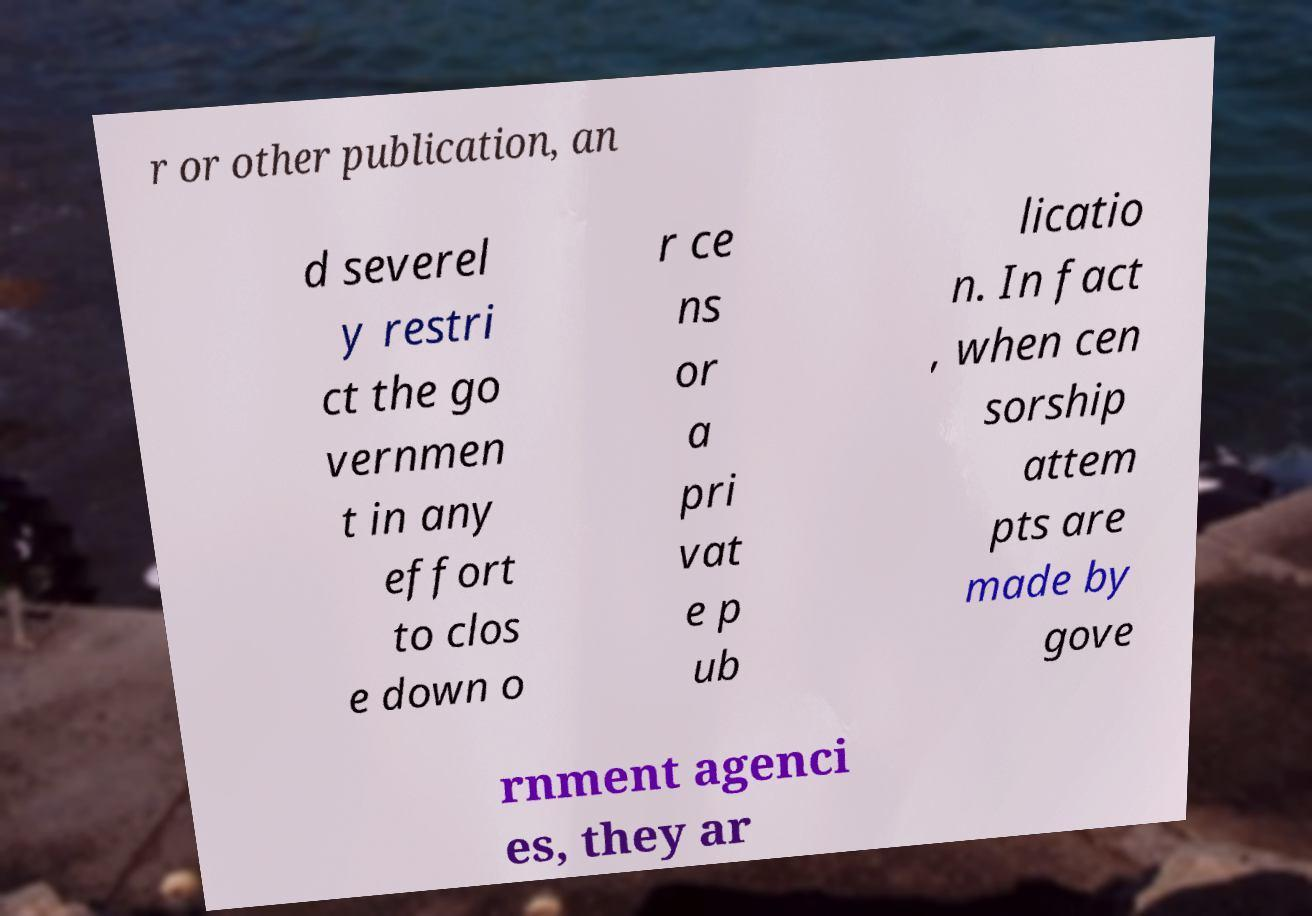What messages or text are displayed in this image? I need them in a readable, typed format. r or other publication, an d severel y restri ct the go vernmen t in any effort to clos e down o r ce ns or a pri vat e p ub licatio n. In fact , when cen sorship attem pts are made by gove rnment agenci es, they ar 